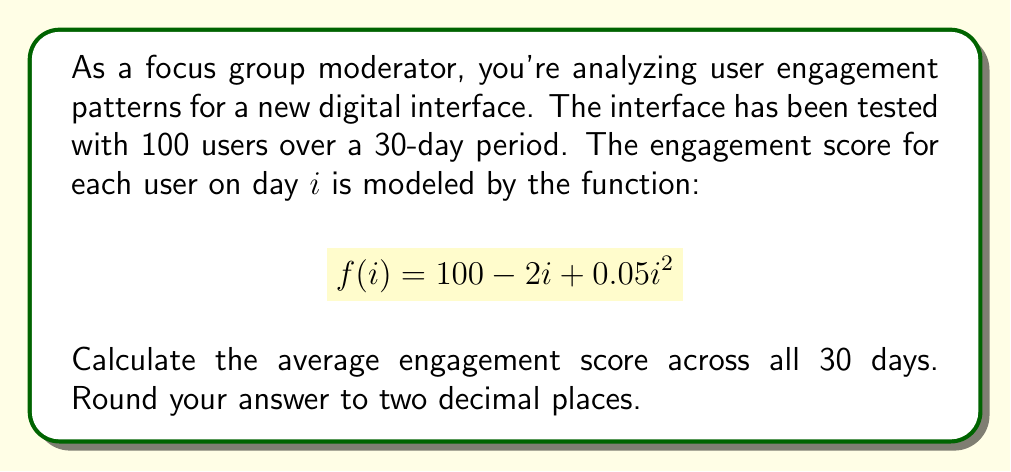Can you answer this question? To solve this problem, we need to follow these steps:

1) First, we need to calculate the sum of engagement scores for all 30 days.

2) Then, we'll divide this sum by 30 to get the average.

Let's break it down:

1) The sum of engagement scores can be calculated using the following formula:

   $$S = \sum_{i=1}^{30} f(i) = \sum_{i=1}^{30} (100 - 2i + 0.05i^2)$$

2) This sum can be simplified using the following formulas:

   $$\sum_{i=1}^{n} 1 = n$$
   $$\sum_{i=1}^{n} i = \frac{n(n+1)}{2}$$
   $$\sum_{i=1}^{n} i^2 = \frac{n(n+1)(2n+1)}{6}$$

3) Applying these to our sum:

   $$S = 100 \sum_{i=1}^{30} 1 - 2 \sum_{i=1}^{30} i + 0.05 \sum_{i=1}^{30} i^2$$
   
   $$= 100(30) - 2(\frac{30(31)}{2}) + 0.05(\frac{30(31)(61)}{6})$$

4) Calculating:

   $$= 3000 - 930 + 457.5 = 2527.5$$

5) Now, we divide by 30 to get the average:

   $$\text{Average} = \frac{2527.5}{30} = 84.25$$

Therefore, the average engagement score across all 30 days is 84.25.
Answer: 84.25 